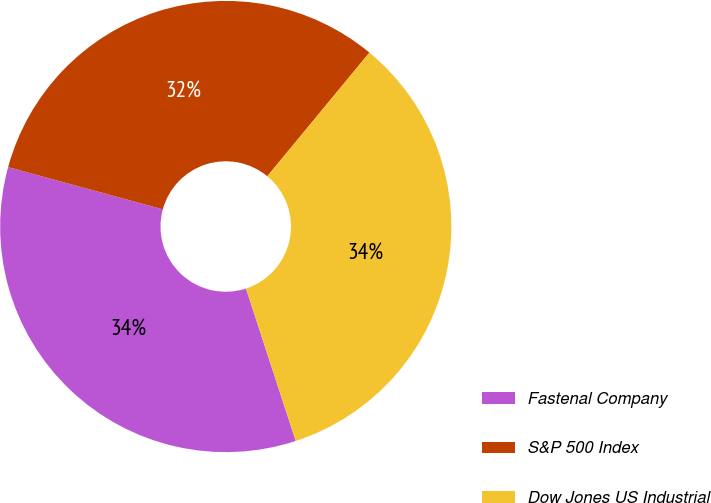Convert chart. <chart><loc_0><loc_0><loc_500><loc_500><pie_chart><fcel>Fastenal Company<fcel>S&P 500 Index<fcel>Dow Jones US Industrial<nl><fcel>34.26%<fcel>31.75%<fcel>33.99%<nl></chart> 